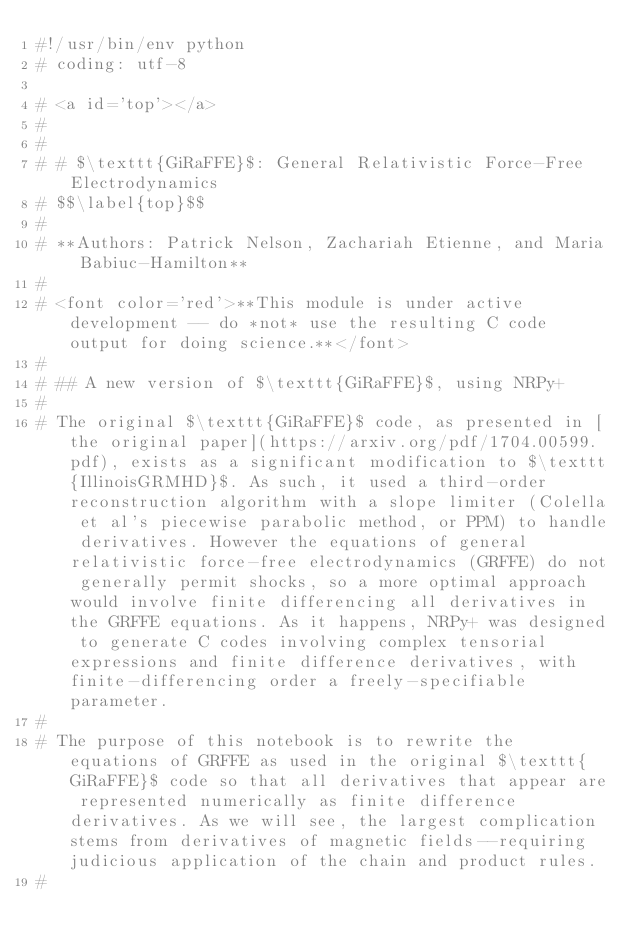<code> <loc_0><loc_0><loc_500><loc_500><_Python_>#!/usr/bin/env python
# coding: utf-8

# <a id='top'></a>
#
#
# # $\texttt{GiRaFFE}$: General Relativistic Force-Free Electrodynamics
# $$\label{top}$$
#
# **Authors: Patrick Nelson, Zachariah Etienne, and Maria Babiuc-Hamilton**
#
# <font color='red'>**This module is under active development -- do *not* use the resulting C code output for doing science.**</font>
#
# ## A new version of $\texttt{GiRaFFE}$, using NRPy+
#
# The original $\texttt{GiRaFFE}$ code, as presented in [the original paper](https://arxiv.org/pdf/1704.00599.pdf), exists as a significant modification to $\texttt{IllinoisGRMHD}$. As such, it used a third-order reconstruction algorithm with a slope limiter (Colella et al's piecewise parabolic method, or PPM) to handle derivatives. However the equations of general relativistic force-free electrodynamics (GRFFE) do not generally permit shocks, so a more optimal approach would involve finite differencing all derivatives in the GRFFE equations. As it happens, NRPy+ was designed to generate C codes involving complex tensorial expressions and finite difference derivatives, with finite-differencing order a freely-specifiable parameter.
#
# The purpose of this notebook is to rewrite the equations of GRFFE as used in the original $\texttt{GiRaFFE}$ code so that all derivatives that appear are represented numerically as finite difference derivatives. As we will see, the largest complication stems from derivatives of magnetic fields--requiring judicious application of the chain and product rules.
#</code> 